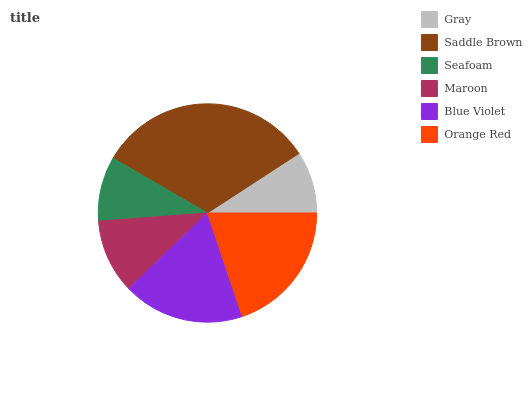Is Gray the minimum?
Answer yes or no. Yes. Is Saddle Brown the maximum?
Answer yes or no. Yes. Is Seafoam the minimum?
Answer yes or no. No. Is Seafoam the maximum?
Answer yes or no. No. Is Saddle Brown greater than Seafoam?
Answer yes or no. Yes. Is Seafoam less than Saddle Brown?
Answer yes or no. Yes. Is Seafoam greater than Saddle Brown?
Answer yes or no. No. Is Saddle Brown less than Seafoam?
Answer yes or no. No. Is Blue Violet the high median?
Answer yes or no. Yes. Is Maroon the low median?
Answer yes or no. Yes. Is Saddle Brown the high median?
Answer yes or no. No. Is Seafoam the low median?
Answer yes or no. No. 